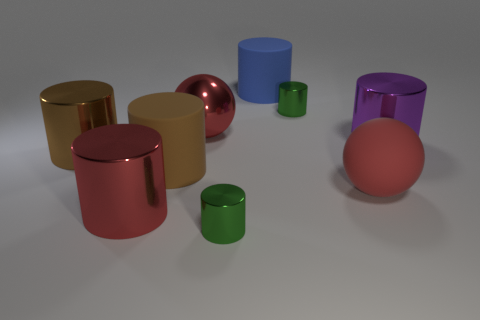Subtract 5 cylinders. How many cylinders are left? 2 Subtract all big rubber cylinders. How many cylinders are left? 5 Subtract all blue cylinders. How many cylinders are left? 6 Add 1 large gray shiny spheres. How many objects exist? 10 Subtract all cyan cylinders. Subtract all cyan spheres. How many cylinders are left? 7 Subtract all cylinders. How many objects are left? 2 Subtract 0 green cubes. How many objects are left? 9 Subtract all cylinders. Subtract all large cyan shiny cylinders. How many objects are left? 2 Add 7 green objects. How many green objects are left? 9 Add 6 tiny metal spheres. How many tiny metal spheres exist? 6 